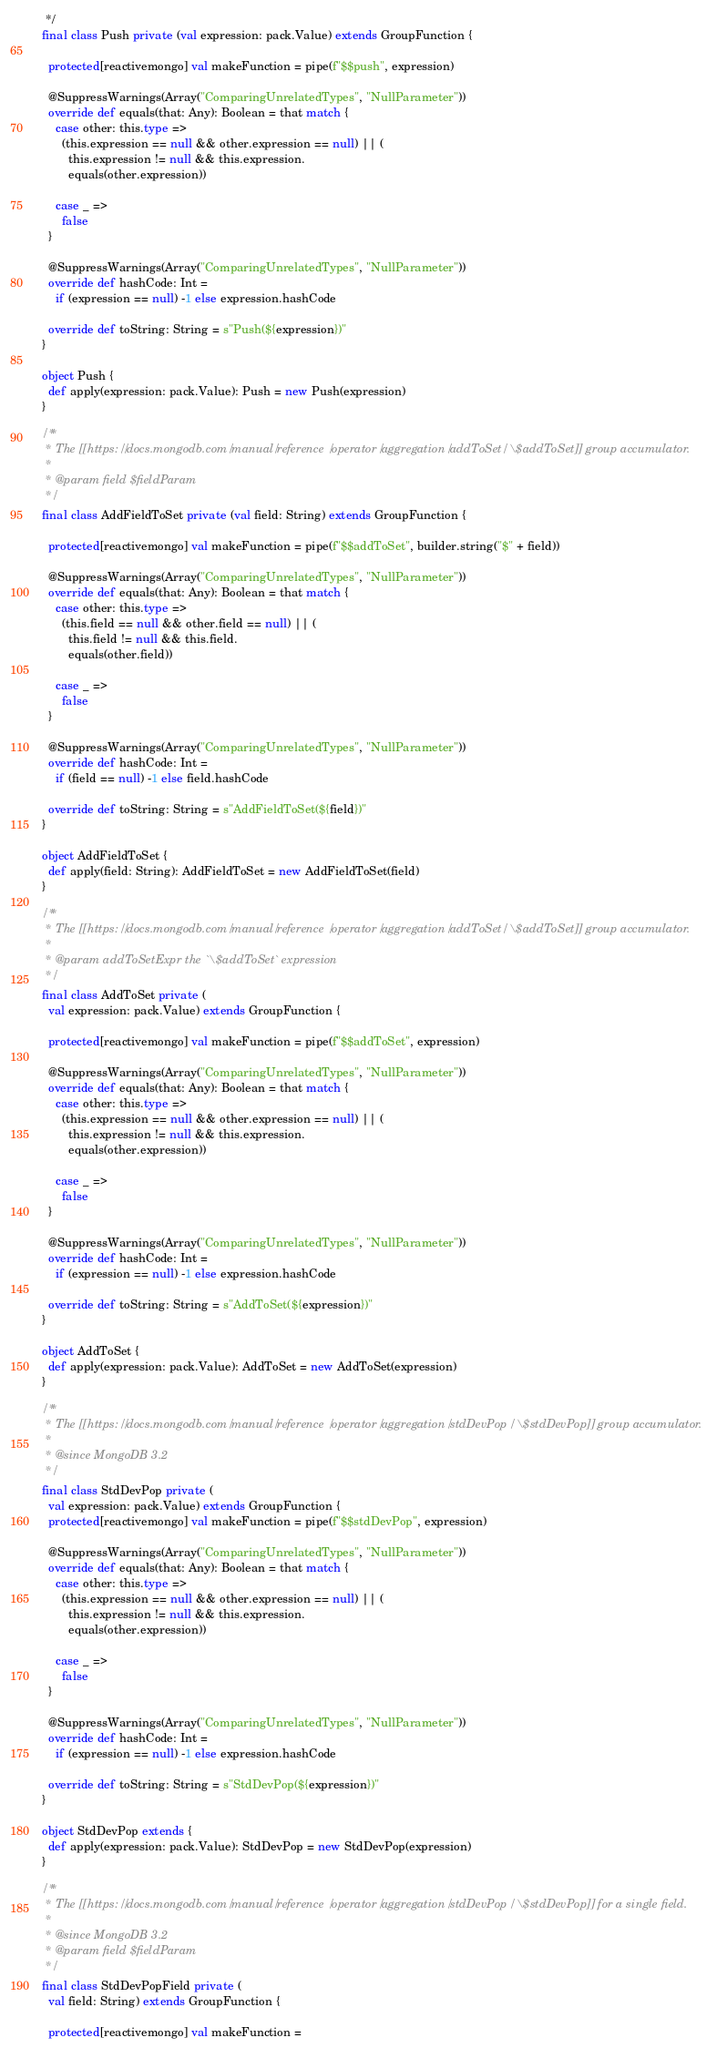Convert code to text. <code><loc_0><loc_0><loc_500><loc_500><_Scala_>   */
  final class Push private (val expression: pack.Value) extends GroupFunction {

    protected[reactivemongo] val makeFunction = pipe(f"$$push", expression)

    @SuppressWarnings(Array("ComparingUnrelatedTypes", "NullParameter"))
    override def equals(that: Any): Boolean = that match {
      case other: this.type =>
        (this.expression == null && other.expression == null) || (
          this.expression != null && this.expression.
          equals(other.expression))

      case _ =>
        false
    }

    @SuppressWarnings(Array("ComparingUnrelatedTypes", "NullParameter"))
    override def hashCode: Int =
      if (expression == null) -1 else expression.hashCode

    override def toString: String = s"Push(${expression})"
  }

  object Push {
    def apply(expression: pack.Value): Push = new Push(expression)
  }

  /**
   * The [[https://docs.mongodb.com/manual/reference/operator/aggregation/addToSet/ \$addToSet]] group accumulator.
   *
   * @param field $fieldParam
   */
  final class AddFieldToSet private (val field: String) extends GroupFunction {

    protected[reactivemongo] val makeFunction = pipe(f"$$addToSet", builder.string("$" + field))

    @SuppressWarnings(Array("ComparingUnrelatedTypes", "NullParameter"))
    override def equals(that: Any): Boolean = that match {
      case other: this.type =>
        (this.field == null && other.field == null) || (
          this.field != null && this.field.
          equals(other.field))

      case _ =>
        false
    }

    @SuppressWarnings(Array("ComparingUnrelatedTypes", "NullParameter"))
    override def hashCode: Int =
      if (field == null) -1 else field.hashCode

    override def toString: String = s"AddFieldToSet(${field})"
  }

  object AddFieldToSet {
    def apply(field: String): AddFieldToSet = new AddFieldToSet(field)
  }

  /**
   * The [[https://docs.mongodb.com/manual/reference/operator/aggregation/addToSet/ \$addToSet]] group accumulator.
   *
   * @param addToSetExpr the `\$addToSet` expression
   */
  final class AddToSet private (
    val expression: pack.Value) extends GroupFunction {

    protected[reactivemongo] val makeFunction = pipe(f"$$addToSet", expression)

    @SuppressWarnings(Array("ComparingUnrelatedTypes", "NullParameter"))
    override def equals(that: Any): Boolean = that match {
      case other: this.type =>
        (this.expression == null && other.expression == null) || (
          this.expression != null && this.expression.
          equals(other.expression))

      case _ =>
        false
    }

    @SuppressWarnings(Array("ComparingUnrelatedTypes", "NullParameter"))
    override def hashCode: Int =
      if (expression == null) -1 else expression.hashCode

    override def toString: String = s"AddToSet(${expression})"
  }

  object AddToSet {
    def apply(expression: pack.Value): AddToSet = new AddToSet(expression)
  }

  /**
   * The [[https://docs.mongodb.com/manual/reference/operator/aggregation/stdDevPop/ \$stdDevPop]] group accumulator.
   *
   * @since MongoDB 3.2
   */
  final class StdDevPop private (
    val expression: pack.Value) extends GroupFunction {
    protected[reactivemongo] val makeFunction = pipe(f"$$stdDevPop", expression)

    @SuppressWarnings(Array("ComparingUnrelatedTypes", "NullParameter"))
    override def equals(that: Any): Boolean = that match {
      case other: this.type =>
        (this.expression == null && other.expression == null) || (
          this.expression != null && this.expression.
          equals(other.expression))

      case _ =>
        false
    }

    @SuppressWarnings(Array("ComparingUnrelatedTypes", "NullParameter"))
    override def hashCode: Int =
      if (expression == null) -1 else expression.hashCode

    override def toString: String = s"StdDevPop(${expression})"
  }

  object StdDevPop extends {
    def apply(expression: pack.Value): StdDevPop = new StdDevPop(expression)
  }

  /**
   * The [[https://docs.mongodb.com/manual/reference/operator/aggregation/stdDevPop/ \$stdDevPop]] for a single field.
   *
   * @since MongoDB 3.2
   * @param field $fieldParam
   */
  final class StdDevPopField private (
    val field: String) extends GroupFunction {

    protected[reactivemongo] val makeFunction =</code> 